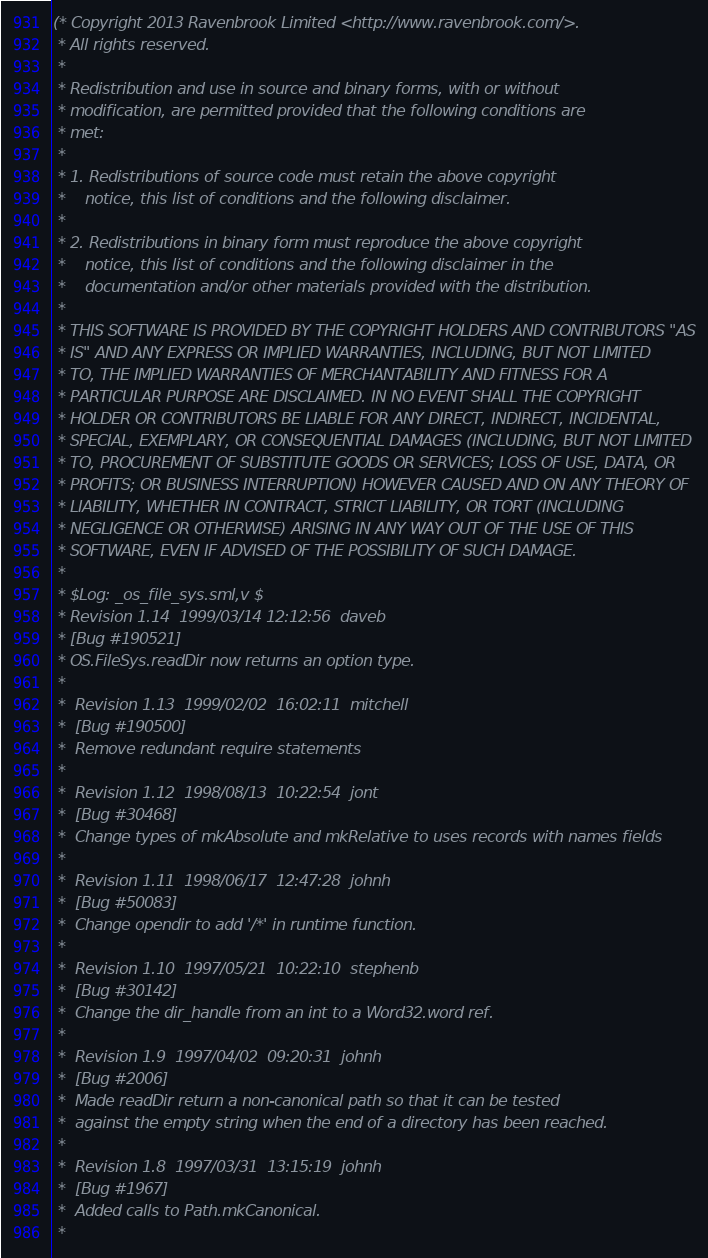Convert code to text. <code><loc_0><loc_0><loc_500><loc_500><_SML_>(* Copyright 2013 Ravenbrook Limited <http://www.ravenbrook.com/>.
 * All rights reserved.
 * 
 * Redistribution and use in source and binary forms, with or without
 * modification, are permitted provided that the following conditions are
 * met:
 * 
 * 1. Redistributions of source code must retain the above copyright
 *    notice, this list of conditions and the following disclaimer.
 * 
 * 2. Redistributions in binary form must reproduce the above copyright
 *    notice, this list of conditions and the following disclaimer in the
 *    documentation and/or other materials provided with the distribution.
 * 
 * THIS SOFTWARE IS PROVIDED BY THE COPYRIGHT HOLDERS AND CONTRIBUTORS "AS
 * IS" AND ANY EXPRESS OR IMPLIED WARRANTIES, INCLUDING, BUT NOT LIMITED
 * TO, THE IMPLIED WARRANTIES OF MERCHANTABILITY AND FITNESS FOR A
 * PARTICULAR PURPOSE ARE DISCLAIMED. IN NO EVENT SHALL THE COPYRIGHT
 * HOLDER OR CONTRIBUTORS BE LIABLE FOR ANY DIRECT, INDIRECT, INCIDENTAL,
 * SPECIAL, EXEMPLARY, OR CONSEQUENTIAL DAMAGES (INCLUDING, BUT NOT LIMITED
 * TO, PROCUREMENT OF SUBSTITUTE GOODS OR SERVICES; LOSS OF USE, DATA, OR
 * PROFITS; OR BUSINESS INTERRUPTION) HOWEVER CAUSED AND ON ANY THEORY OF
 * LIABILITY, WHETHER IN CONTRACT, STRICT LIABILITY, OR TORT (INCLUDING
 * NEGLIGENCE OR OTHERWISE) ARISING IN ANY WAY OUT OF THE USE OF THIS
 * SOFTWARE, EVEN IF ADVISED OF THE POSSIBILITY OF SUCH DAMAGE.
 *
 * $Log: _os_file_sys.sml,v $
 * Revision 1.14  1999/03/14 12:12:56  daveb
 * [Bug #190521]
 * OS.FileSys.readDir now returns an option type.
 *
 *  Revision 1.13  1999/02/02  16:02:11  mitchell
 *  [Bug #190500]
 *  Remove redundant require statements
 *
 *  Revision 1.12  1998/08/13  10:22:54  jont
 *  [Bug #30468]
 *  Change types of mkAbsolute and mkRelative to uses records with names fields
 *
 *  Revision 1.11  1998/06/17  12:47:28  johnh
 *  [Bug #50083]
 *  Change opendir to add '/*' in runtime function.
 *
 *  Revision 1.10  1997/05/21  10:22:10  stephenb
 *  [Bug #30142]
 *  Change the dir_handle from an int to a Word32.word ref.
 *
 *  Revision 1.9  1997/04/02  09:20:31  johnh
 *  [Bug #2006]
 *  Made readDir return a non-canonical path so that it can be tested
 *  against the empty string when the end of a directory has been reached.
 *
 *  Revision 1.8  1997/03/31  13:15:19  johnh
 *  [Bug #1967]
 *  Added calls to Path.mkCanonical.
 *</code> 